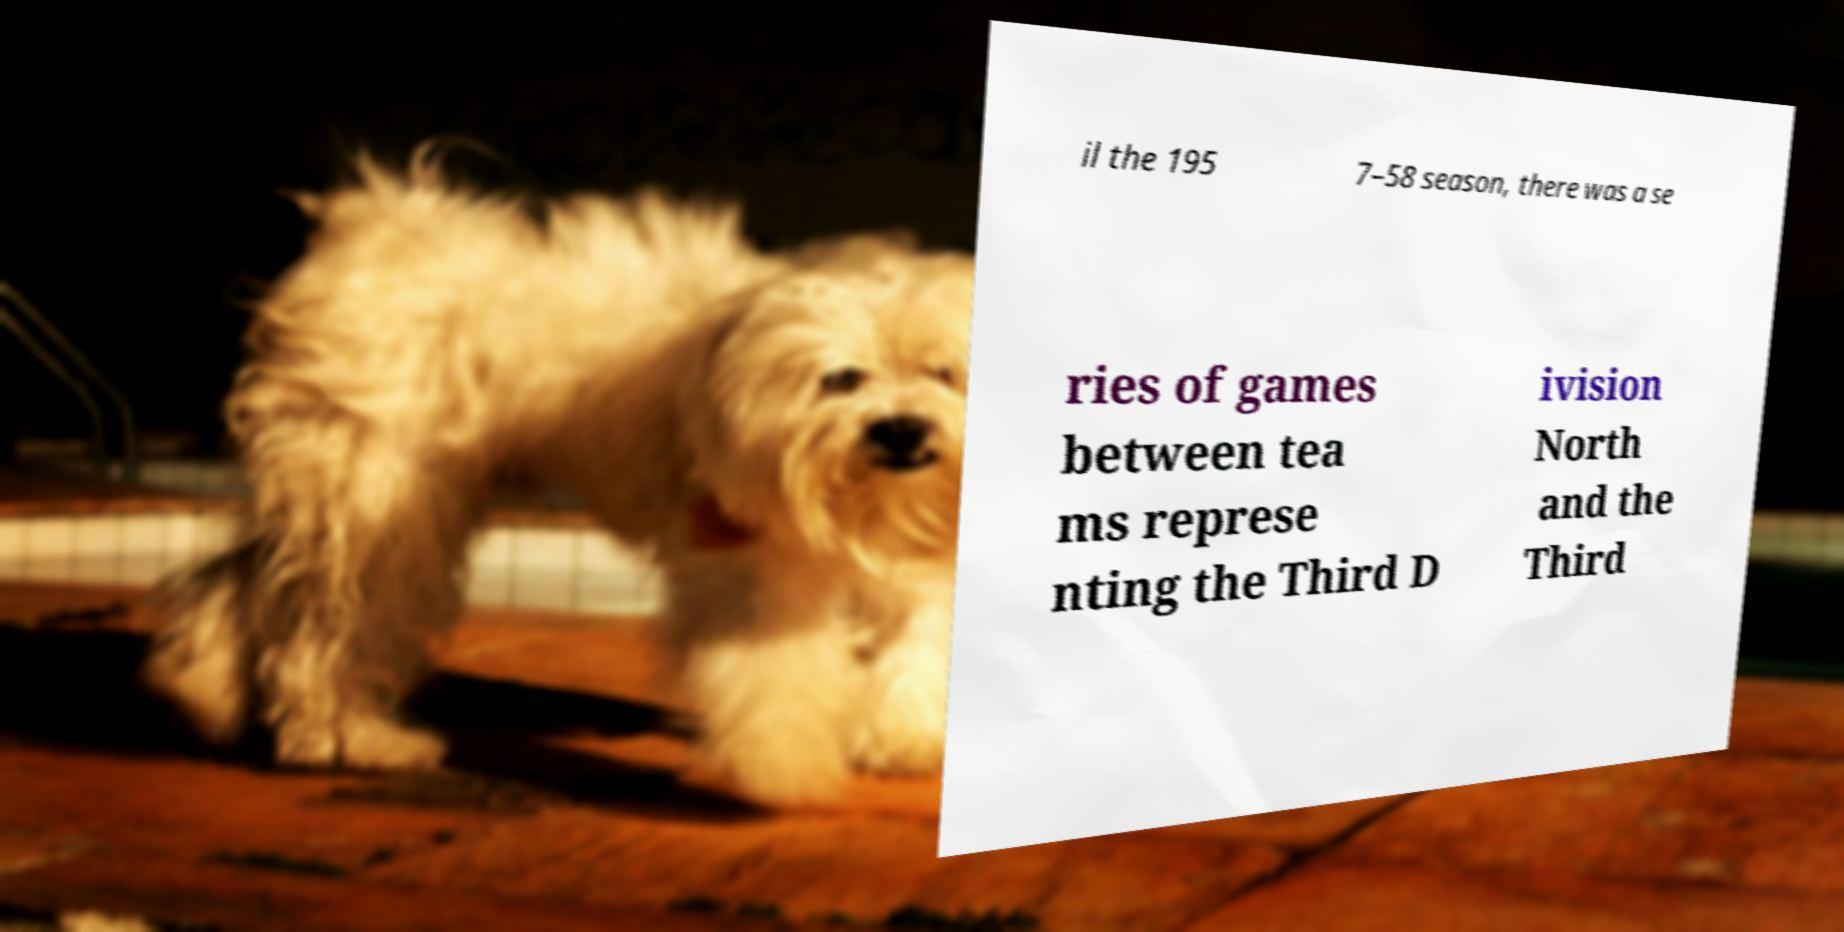What messages or text are displayed in this image? I need them in a readable, typed format. il the 195 7–58 season, there was a se ries of games between tea ms represe nting the Third D ivision North and the Third 